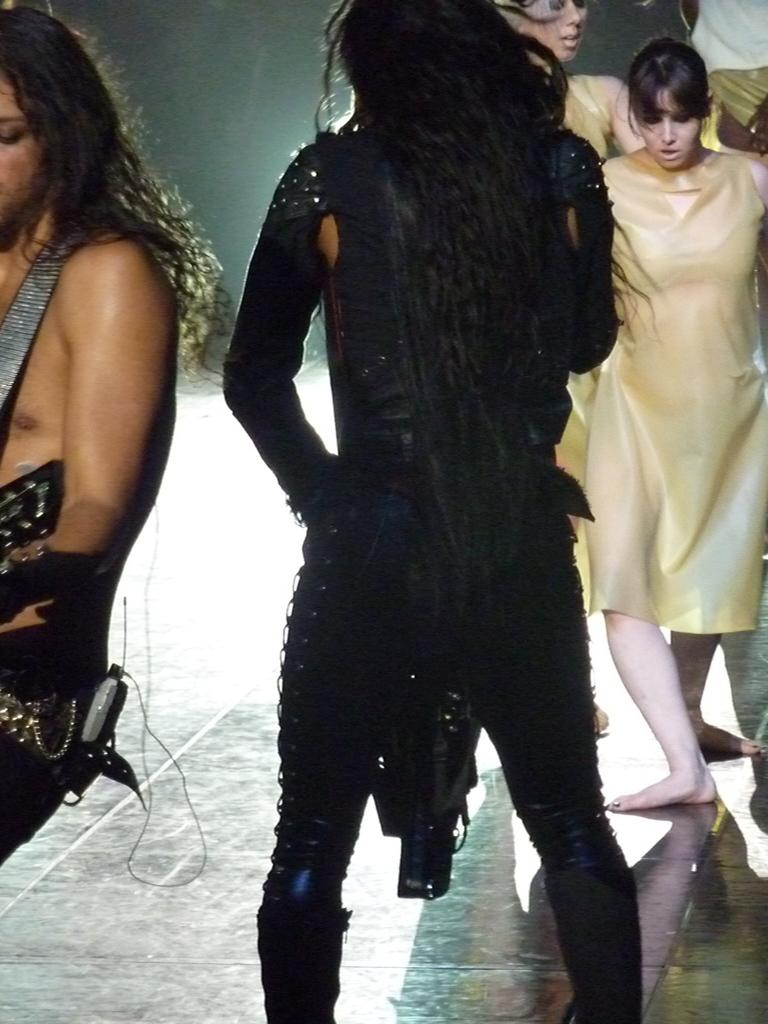Who or what is present in the image? There are people in the image. Where are the people located in the image? The people are on the floor. Can you describe the positioning of the people in the image? The people are in the center of the image. What type of paste is being used by the people in the image? There is no paste present in the image; the people are simply on the floor. 